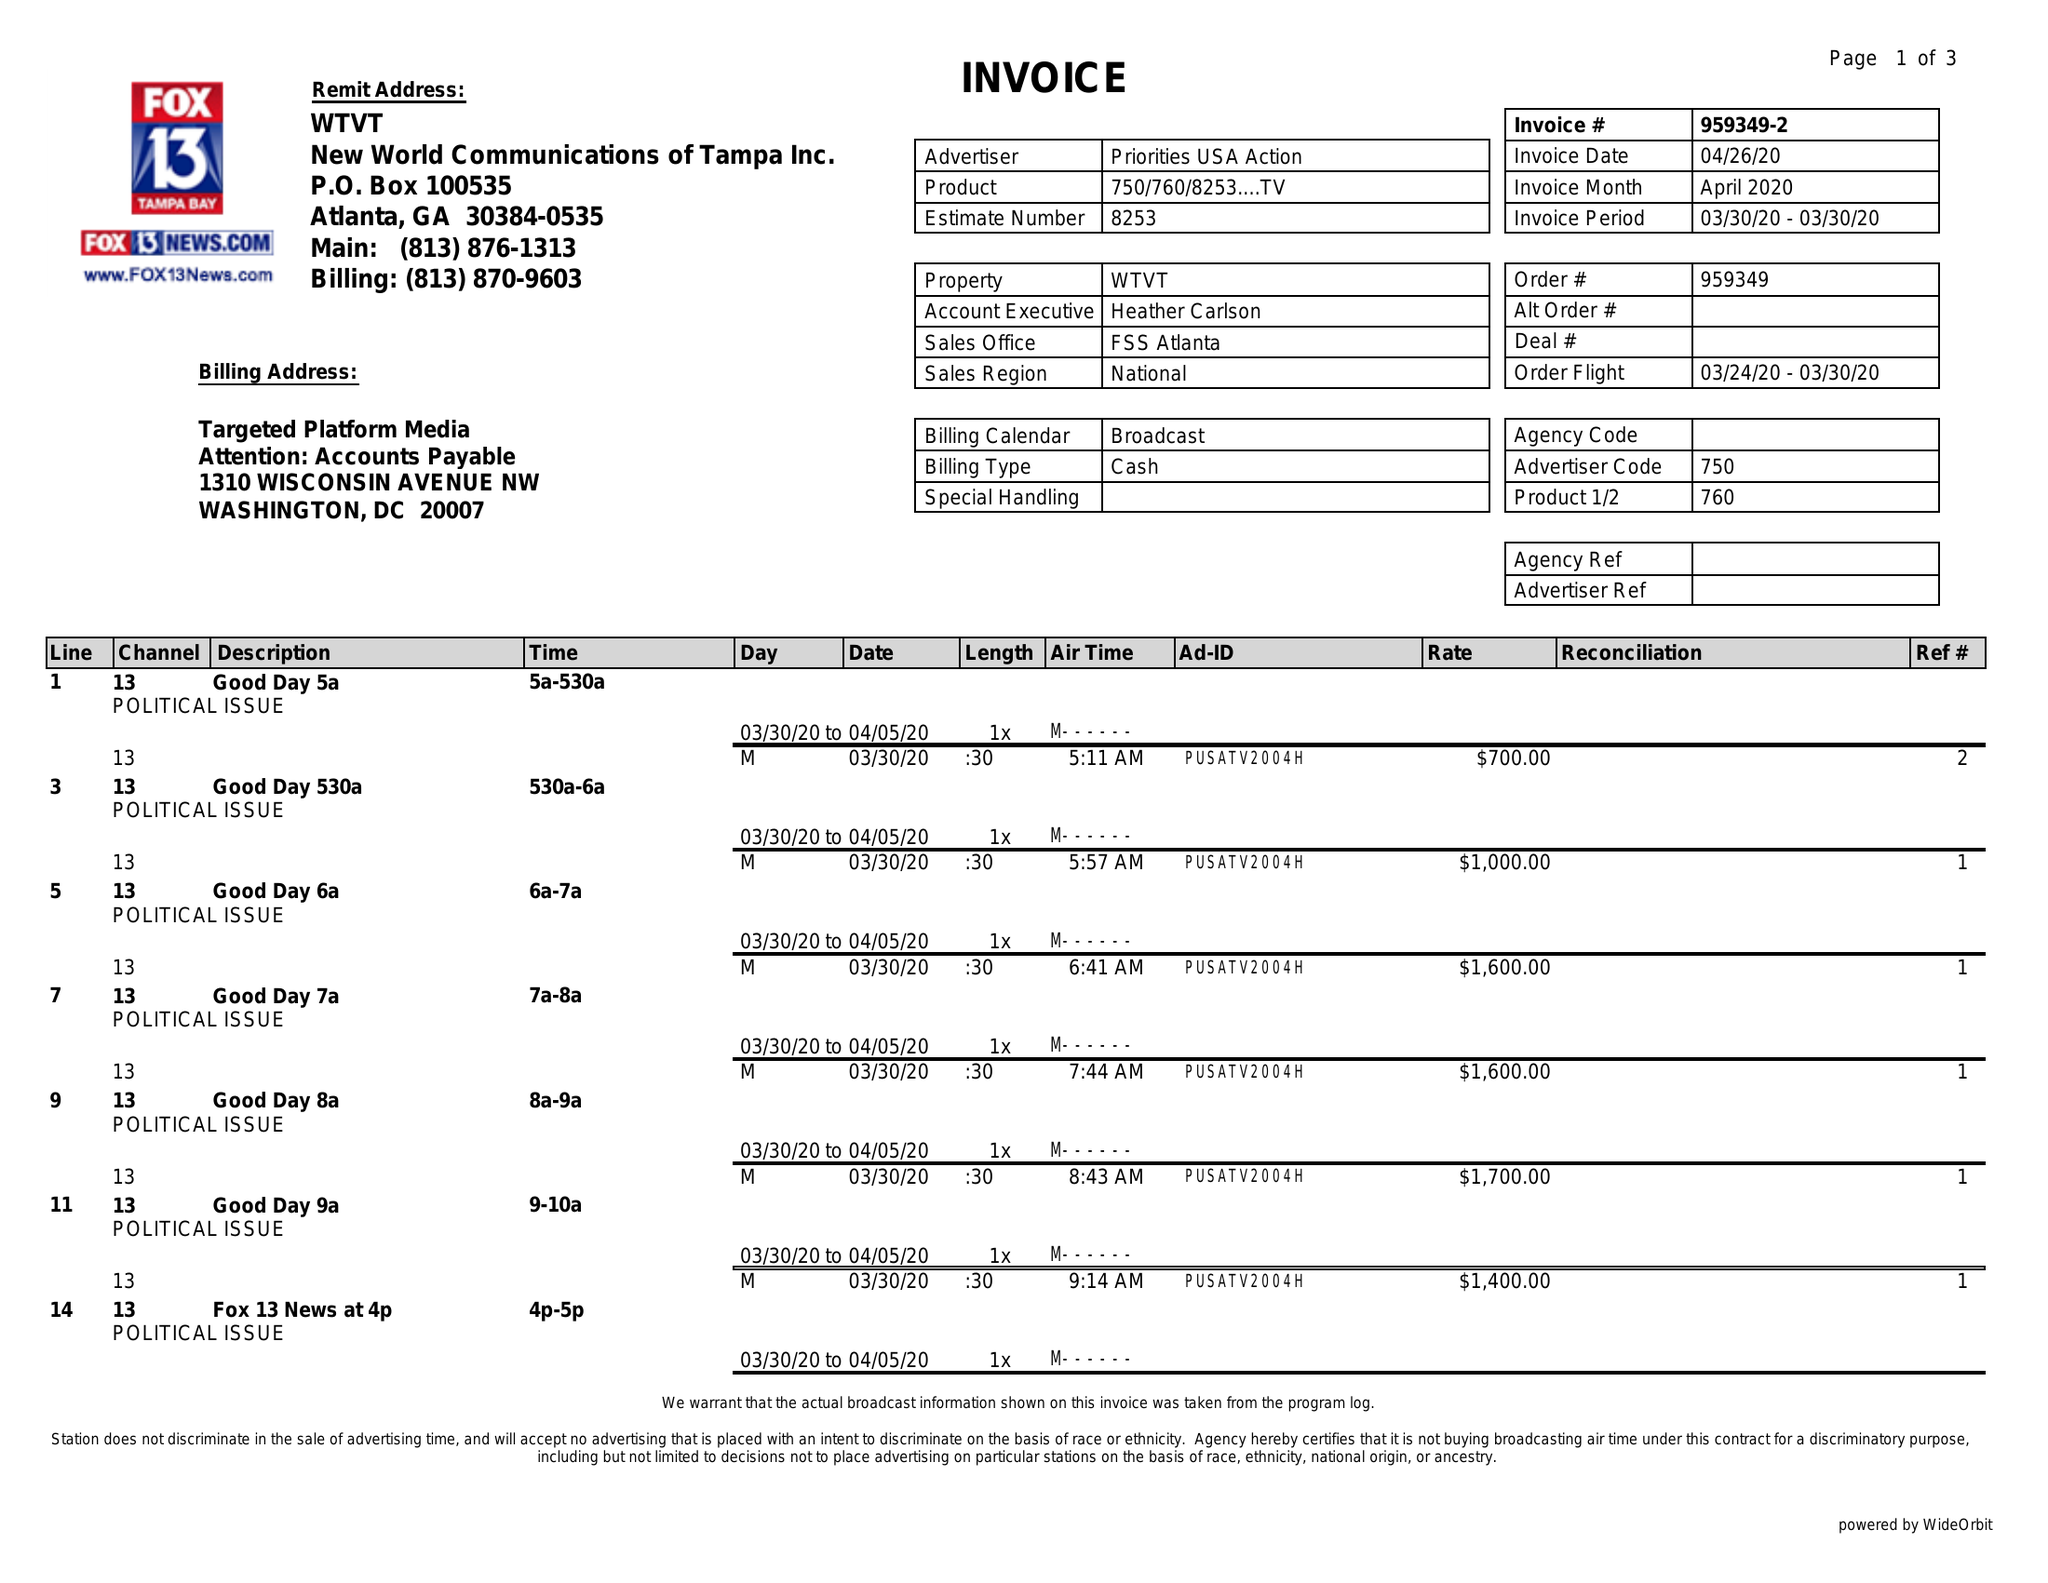What is the value for the gross_amount?
Answer the question using a single word or phrase. 17000.00 